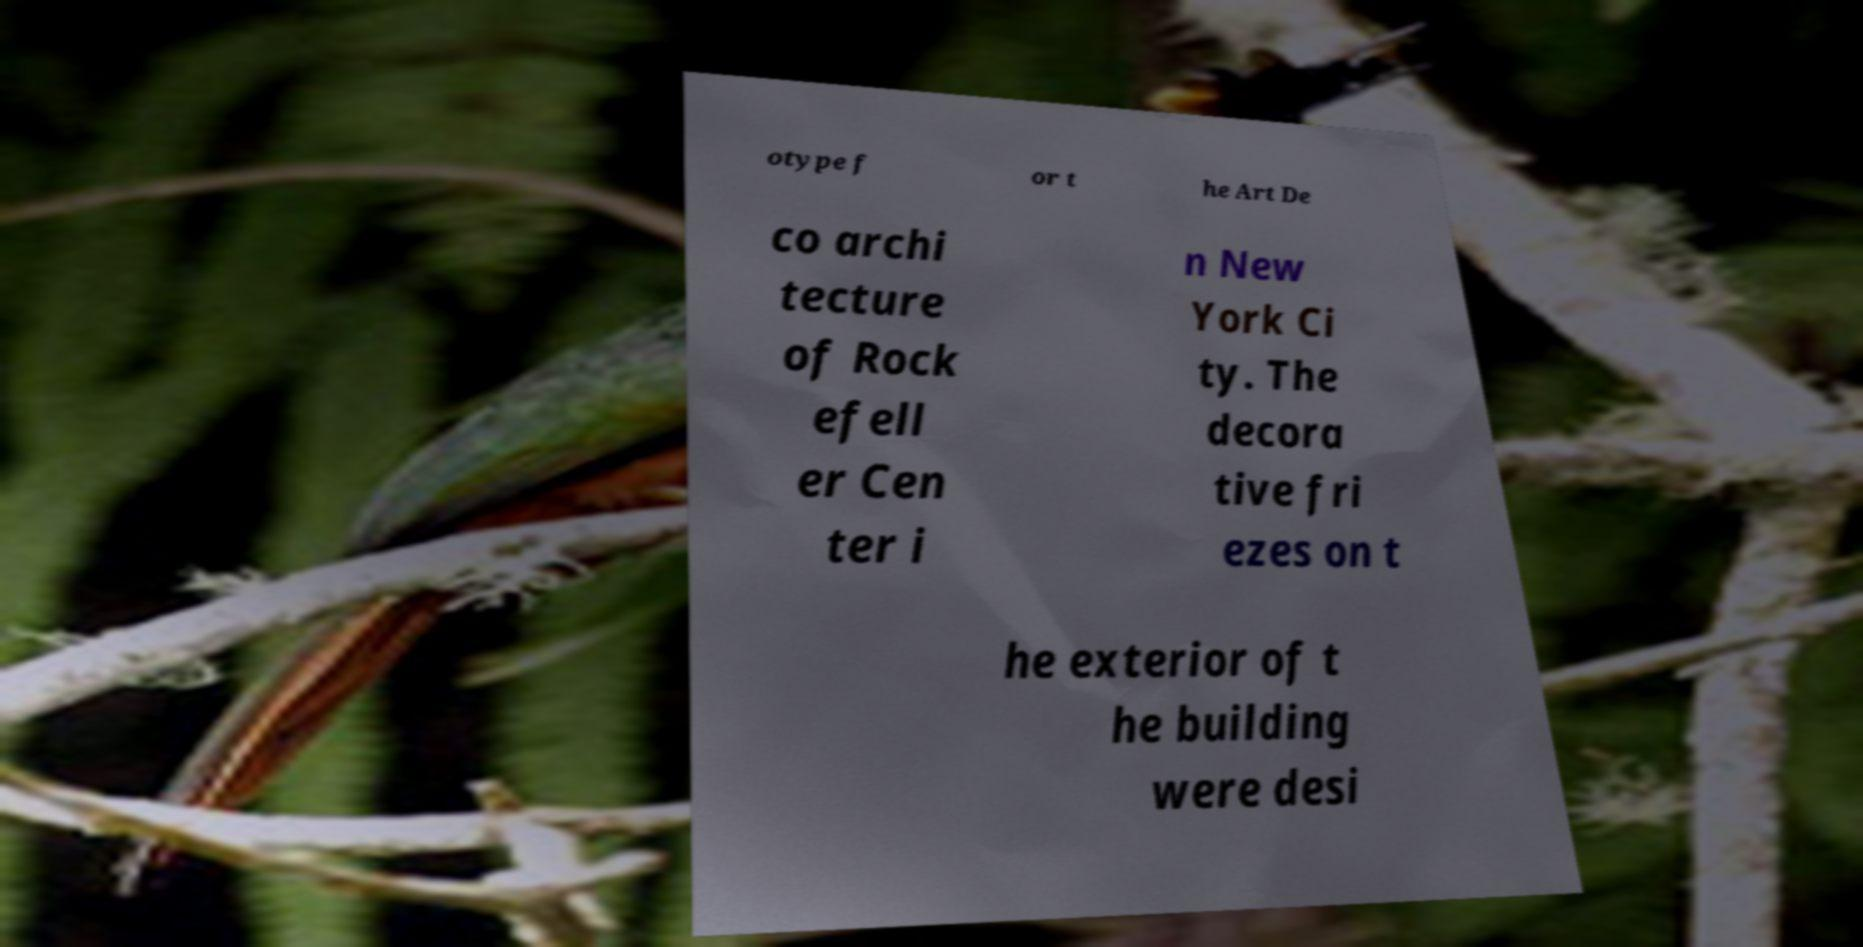Can you read and provide the text displayed in the image?This photo seems to have some interesting text. Can you extract and type it out for me? otype f or t he Art De co archi tecture of Rock efell er Cen ter i n New York Ci ty. The decora tive fri ezes on t he exterior of t he building were desi 